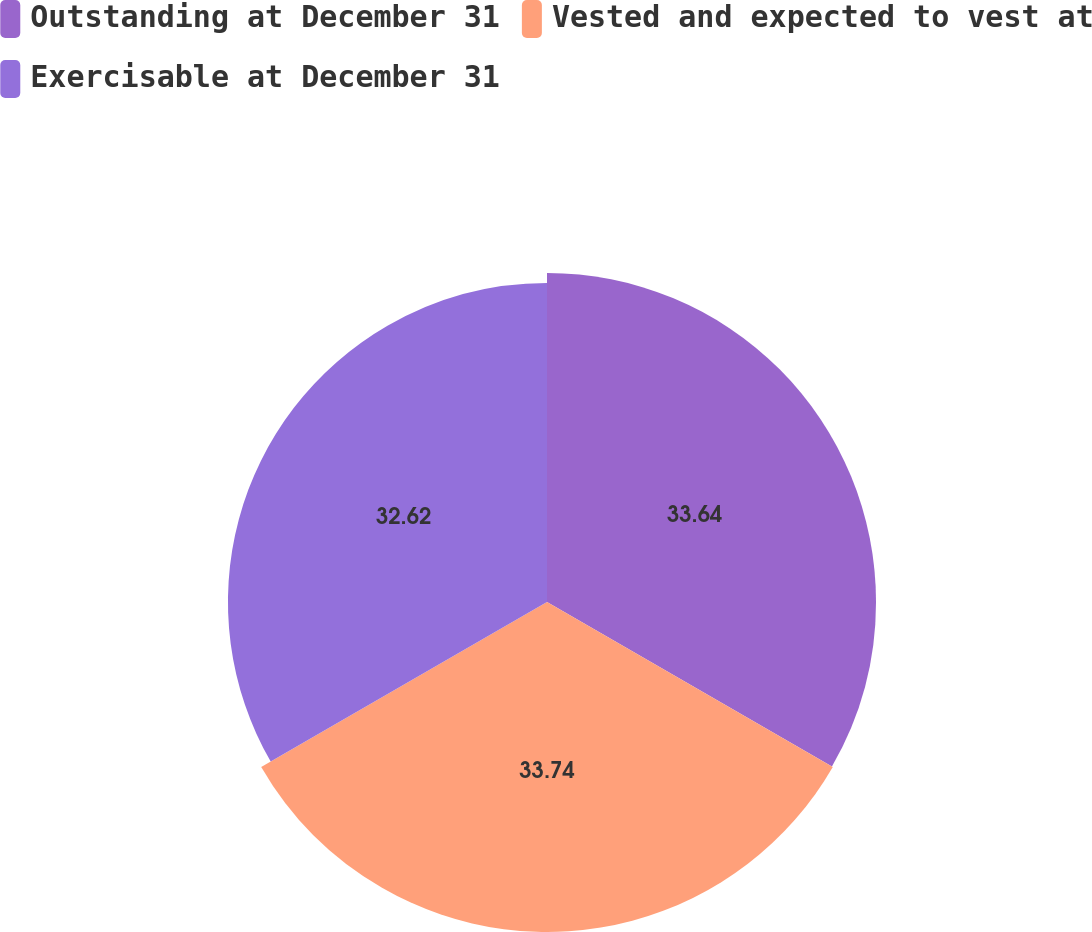Convert chart. <chart><loc_0><loc_0><loc_500><loc_500><pie_chart><fcel>Outstanding at December 31<fcel>Vested and expected to vest at<fcel>Exercisable at December 31<nl><fcel>33.64%<fcel>33.74%<fcel>32.62%<nl></chart> 